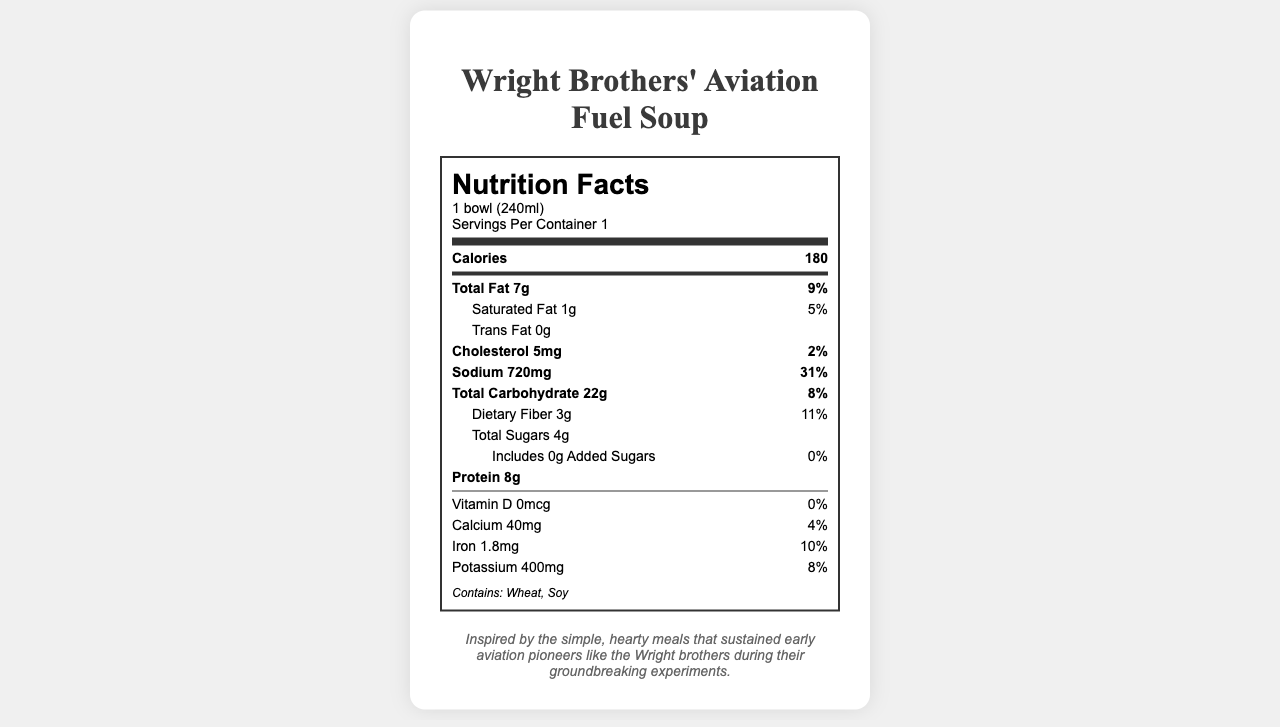what is the serving size for Wright Brothers' Aviation Fuel Soup? The serving size is directly mentioned at the beginning of the nutrition label, indicated as "1 bowl (240ml)".
Answer: 1 bowl (240ml) how many calories are in one bowl of the soup? The calories are listed at the top of the nutrition information, showing that one bowl contains 180 calories.
Answer: 180 calories what percentage of the daily value for sodium does one serving of the soup provide? The nutrient breakdown shows that sodium contributes to 31% of the daily value in one serving.
Answer: 31% how much protein is in the soup? The protein amount is listed under the nutrition facts at 8 grams per serving.
Answer: 8g What is the price of Wright Brothers' Aviation Fuel Soup? The document indicates that the price is $6.99, given in the "price" section.
Answer: $6.99 which allergens are contained in the soup? A) Dairy, Soy B) Wheat, Soy C) Nuts, Dairy D) Gluten, Dairy The allergens listed in the document are "Contains: Wheat, Soy".
Answer: B) Wheat, Soy how many grams of dietary fiber are in one bowl of the soup? The dietary fiber amount in the soup is listed as 3 grams per serving.
Answer: 3g Is the Wright Brothers' Aviation Fuel Soup gluten-free? The dietary considerations indicate that the soup is not gluten-free.
Answer: No What is the historical context provided for the soup? The historical context is explicitly mentioned in the document, under "historical_context".
Answer: Inspired by the simple, hearty meals that sustained early aviation pioneers like the Wright brothers during their groundbreaking experiments. What are the main ingredients in the soup? These are listed in the "ingredients" section of the document.
Answer: Vegetable broth, Carrots, Celery, Onions, Potatoes, Barley, Olive oil, Garlic, Thyme, Salt, Black pepper What percentage of revenue from the soup is allocated to the general museum fund? The revenue allocation section shows that 20% of the proceeds go to the general museum fund.
Answer: 20% how much cholesterol does one serving of the soup contain? The amount of cholesterol is listed as 5mg within the nutrition facts.
Answer: 5mg What is the purpose of using local farms to source ingredients for the soup? A) To reduce costs B) To align with museum's environmental responsibility C) To add exotic flavors D) To increase production speed The document mentions that sourcing ingredients from local farms helps reduce carbon footprint, aligning with the museum's commitment to environmental responsibility.
Answer: B) To align with museum's environmental responsibility how much iron does the soup provide in terms of daily value percentage? The iron content is shown as providing 10% of the daily value.
Answer: 10% how many servings are in one container of the Wright Brothers' Aviation Fuel Soup? The document notes that there is 1 serving per container.
Answer: 1 serving per container Summarize the main idea of the document. The document offers a comprehensive view of all relevant details about the Wright Brothers' Aviation Fuel Soup including nutritional facts, the historical inspiration behind the dish, and how the revenue is allocated.
Answer: The document provides nutritional information, historical context, ingredients, allergen warnings, dietary considerations, price, and revenue allocation for the Wright Brothers' Aviation Fuel Soup being served at the museum cafeteria. how much trans fat is in the soup? The trans fat amount is explicitly listed as 0 grams in the nutrition information.
Answer: 0g What is the curator fun fact mentioned for Wright Brothers' Aviation Fuel Soup? The document has a section called "curator_fun_fact" that gives this specific detail.
Answer: The fun fact states that the soup’s golden color is reminiscent of early aviation fuel, connecting the culinary offerings to the aeronautical exhibits. Does the soup contain any added sugars? The document indicates that there are 0 grams of added sugars in the soup.
Answer: No What types of dietary considerations are listed for the soup? The dietary considerations section specifies that the soup is vegetarian and vegan but not gluten-free.
Answer: Vegetarian, Vegan, Not Gluten-Free What is the total carbohydrate content in the soup? The total carbohydrate content is listed as 22 grams in the nutrition facts.
Answer: 22g 